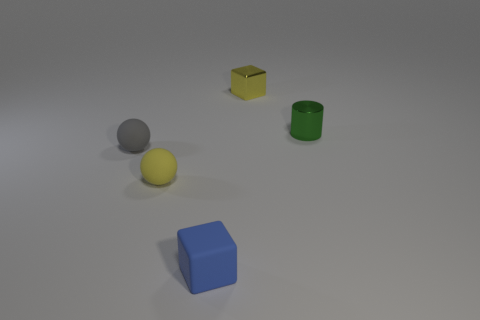Do the small cylinder and the small cube that is in front of the yellow metal block have the same color?
Your answer should be very brief. No. Are there fewer small blue cylinders than small green cylinders?
Keep it short and to the point. Yes. Is the number of small spheres that are to the right of the tiny gray sphere greater than the number of green shiny cylinders that are on the left side of the blue thing?
Provide a short and direct response. Yes. Is the material of the green object the same as the yellow ball?
Your answer should be compact. No. There is a yellow object that is to the right of the small rubber cube; how many tiny yellow matte balls are to the left of it?
Make the answer very short. 1. Is the color of the tiny matte thing that is in front of the yellow sphere the same as the tiny cylinder?
Your answer should be very brief. No. How many things are either gray things or tiny yellow things that are on the right side of the yellow ball?
Provide a short and direct response. 2. There is a yellow thing in front of the tiny gray ball; is it the same shape as the small metallic object on the right side of the yellow metal cube?
Your response must be concise. No. Is there any other thing of the same color as the shiny cube?
Offer a terse response. Yes. What shape is the blue object that is the same material as the gray ball?
Offer a very short reply. Cube. 